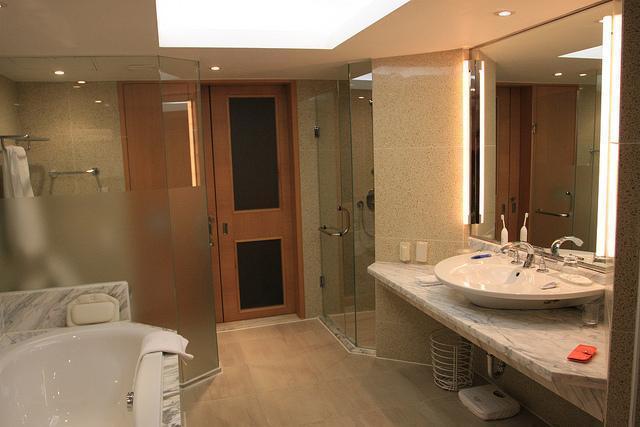What color is the little purse on the marble countertop next to the big raised sink?
Answer the question by selecting the correct answer among the 4 following choices.
Options: Green, blue, orange, pink. Orange. 